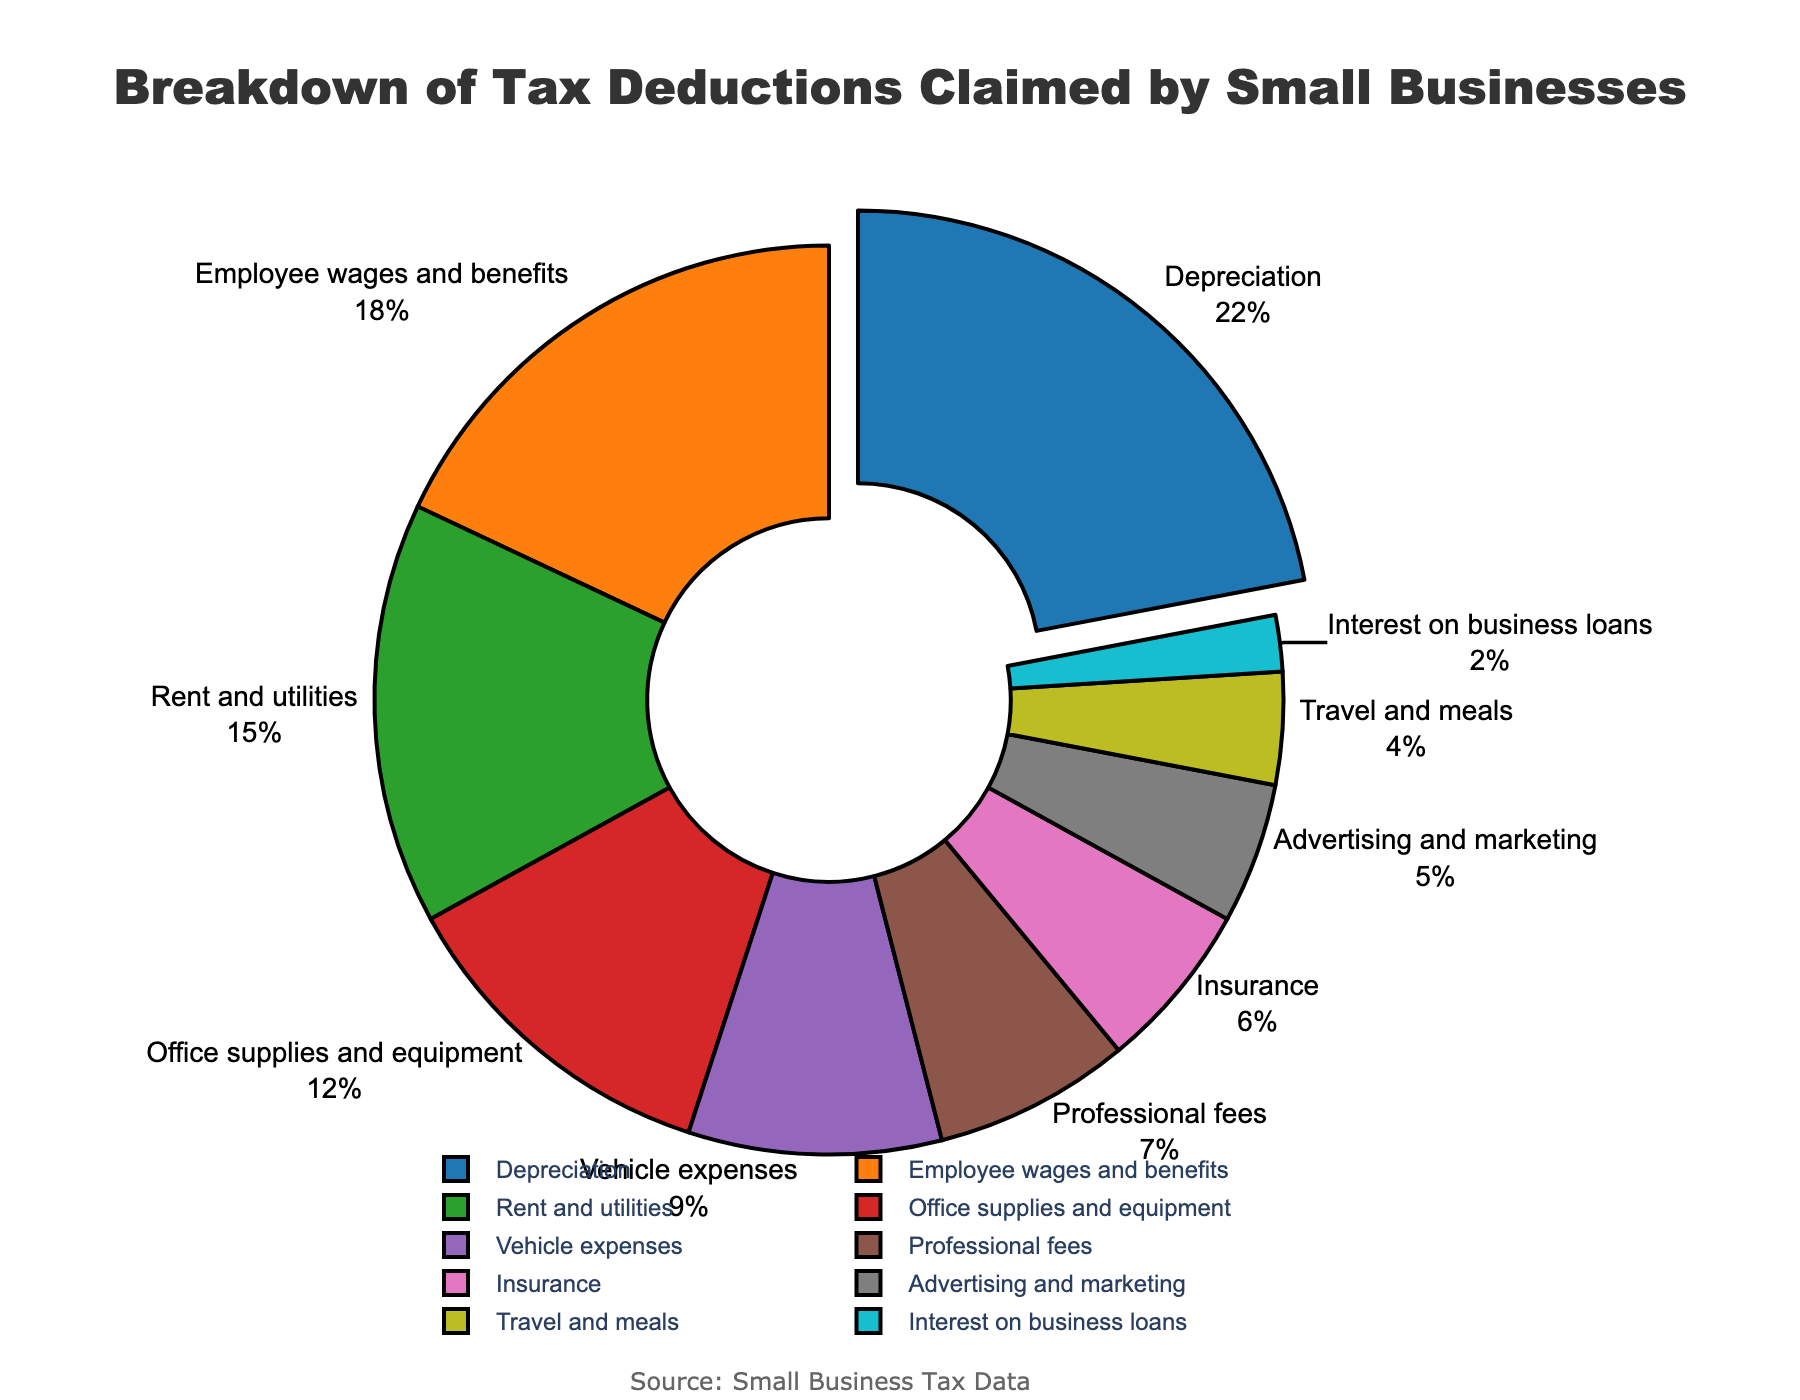What percentage of tax deductions is from Depreciation? Look at the part of the pie chart labeled 'Depreciation' and read the percentage value next to it.
Answer: 22% Which category claims the highest percentage of tax deductions? Identify the category with the largest section of the pie chart. The largest section is usually positioned at the top or top right of the chart.
Answer: Depreciation How much more is claimed for Employee wages and benefits than for Advertising and marketing? Locate the percentages for both 'Employee wages and benefits' and 'Advertising and marketing'. Subtract the smaller percentage (Advertising and marketing) from the larger one (Employee wages and benefits): 18% - 5% = 13%.
Answer: 13% Which category contributes the least to the tax deductions? Identify the smallest section of the pie chart by comparing all sections. The smallest section is labeled 'Interest on business loans'.
Answer: Interest on business loans What is the combined percentage for Rent and utilities and Vehicle expenses? Identify the percentages for 'Rent and utilities' (15%) and 'Vehicle expenses' (9%). Add these two values together: 15% + 9% = 24%.
Answer: 24% Which two categories have the lowest combined total in terms of tax deductions? Find the two smallest sections. These are 'Interest on business loans' (2%) and 'Travel and meals' (4%). Add their percentages: 2% + 4% = 6%.
Answer: Interest on business loans and Travel and meals How many categories contribute more than 10% each to the tax deductions? Identify sections with a percentage higher than 10%. These are 'Depreciation' (22%), 'Employee wages and benefits' (18%), 'Rent and utilities' (15%), and 'Office supplies and equipment' (12%). Count them: 4 categories.
Answer: 4 Are Vehicle expenses or Professional fees higher in terms of tax deductions? Compare the percentages for 'Vehicle expenses' (9%) and 'Professional fees' (7%). 'Vehicle expenses' is greater than 'Professional fees'.
Answer: Vehicle expenses What is the total percentage claimed by categories contributing less than 10% each? Identify all categories with percentages less than 10%. These are 'Vehicle expenses' (9%), 'Professional fees' (7%), 'Insurance' (6%), 'Advertising and marketing' (5%), 'Travel and meals' (4%), and 'Interest on business loans' (2%). Add them together: 9% + 7% + 6% + 5% + 4% + 2% = 33%.
Answer: 33% Which category has a closer contribution to Vehicle expenses, Insurance or Professional fees? Compare the differences between 'Vehicle expenses' (9%) and 'Insurance' (6%), and between 'Vehicle expenses' and 'Professional fees' (7%). The difference between 'Vehicle expenses' and 'Professional fees' is 2%, which is smaller than the difference between 'Vehicle expenses' and 'Insurance' (3%).
Answer: Professional fees 